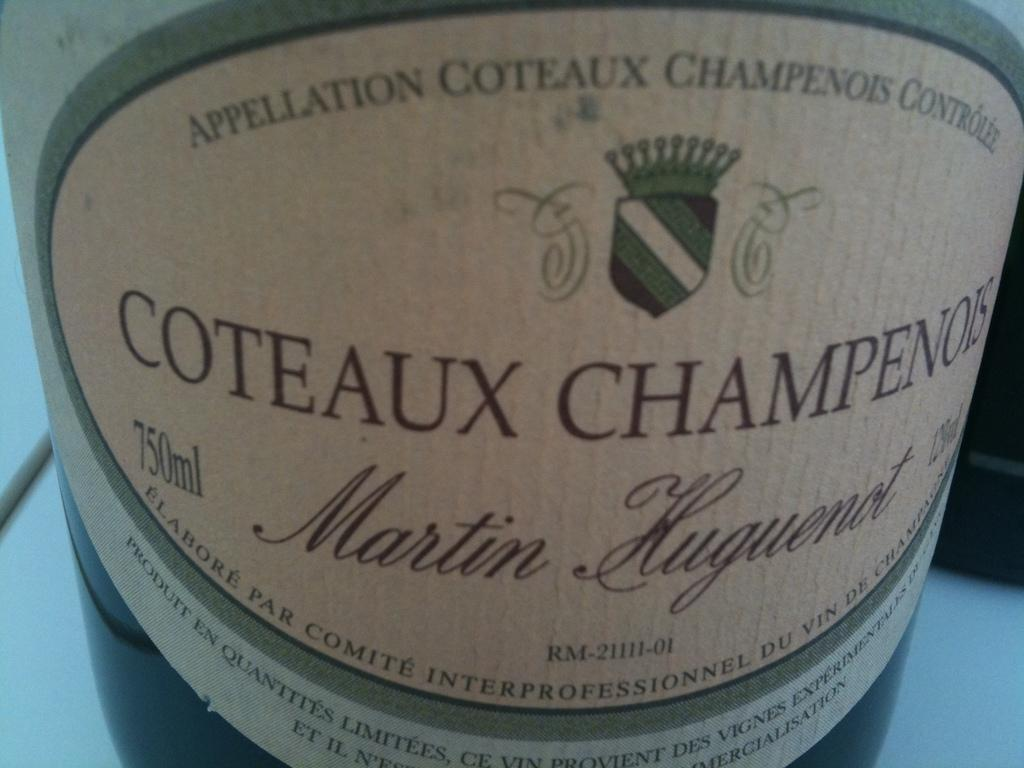<image>
Write a terse but informative summary of the picture. A bottle of foreign champagne with the label "Coteaux Champenois" 